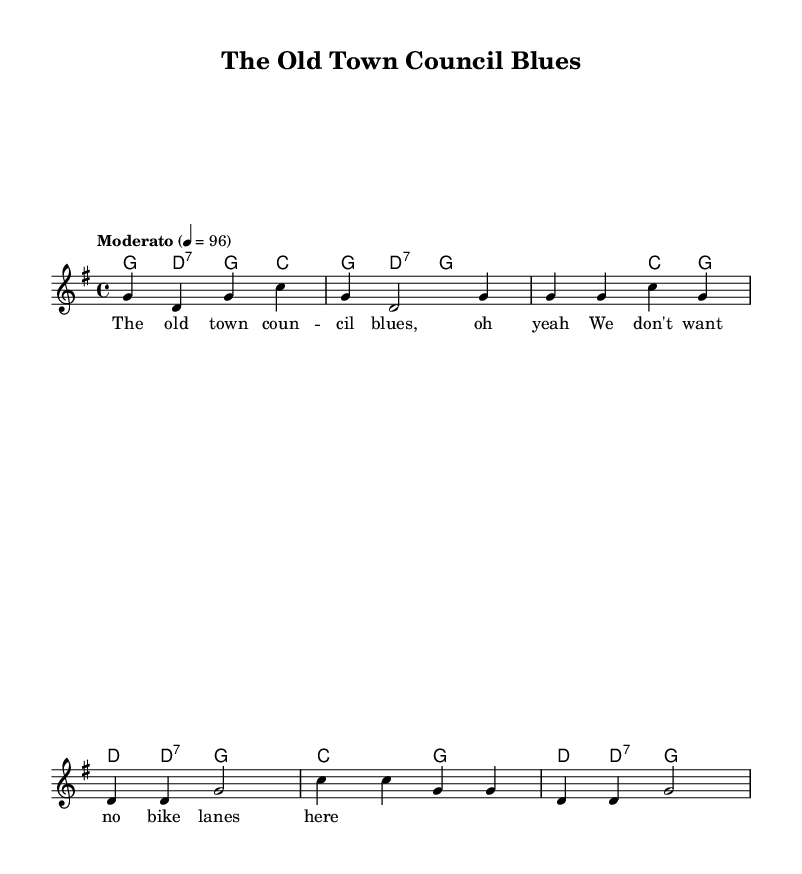What is the key signature of this music? The key signature indicates that the music is in G major, which has one sharp (F#).
Answer: G major What is the time signature of this music? The time signature is found at the beginning of the score and is indicated as 4/4, meaning there are four beats in each measure.
Answer: 4/4 What is the tempo marking for this music? The tempo marking is marked as "Moderato" and indicates a moderate speed, set at a quarter note equals 96 beats per minute.
Answer: Moderato, 96 How many measures are in the intro section? The intro section consists of 2 measures as indicated by the grouping of notes before the first verse starts.
Answer: 2 measures How many notes are in the first chorus? The first chorus consists of 8 notes, which can be counted from the notes provided in the chorus section of the sheet music.
Answer: 8 notes What type of lyrics are included in this music? The lyrics present in this piece are a comment on local issues, specifically opposing bike lanes as indicated in the placeholder lyrics.
Answer: Traditional folk lyrics What is the chord progression for the first verse? The chord progression for the first verse is G, C, and D, as indicated by the harmonies written above the melody notes in the score.
Answer: G, C, D 